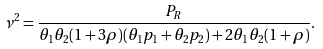<formula> <loc_0><loc_0><loc_500><loc_500>\nu ^ { 2 } = \frac { P _ { R } } { \theta _ { 1 } \theta _ { 2 } ( 1 + 3 \rho ) ( \theta _ { 1 } p _ { 1 } + \theta _ { 2 } p _ { 2 } ) + 2 \theta _ { 1 } \theta _ { 2 } ( 1 + \rho ) } .</formula> 